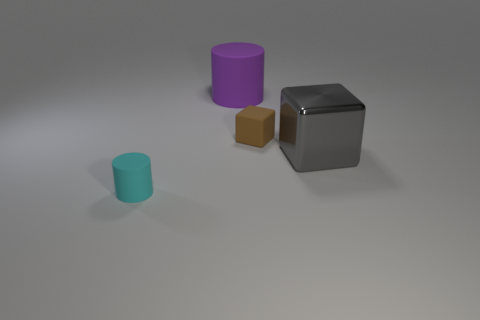Is the number of cyan rubber things that are behind the tiny brown cube the same as the number of large purple things left of the gray cube?
Your answer should be very brief. No. What is the shape of the large thing that is behind the rubber object to the right of the big purple matte cylinder?
Your response must be concise. Cylinder. What material is the purple object that is the same shape as the small cyan rubber thing?
Ensure brevity in your answer.  Rubber. The rubber cylinder that is the same size as the matte block is what color?
Your answer should be compact. Cyan. Are there the same number of brown objects left of the big purple matte thing and large red cylinders?
Ensure brevity in your answer.  Yes. What is the color of the cylinder that is on the right side of the tiny thing that is in front of the gray shiny object?
Offer a terse response. Purple. There is a cylinder to the left of the thing behind the brown block; what is its size?
Make the answer very short. Small. What number of other things are the same size as the rubber cube?
Give a very brief answer. 1. There is a cylinder that is in front of the big object that is right of the cylinder behind the gray shiny block; what color is it?
Offer a terse response. Cyan. What number of other objects are there of the same shape as the purple matte thing?
Provide a short and direct response. 1. 